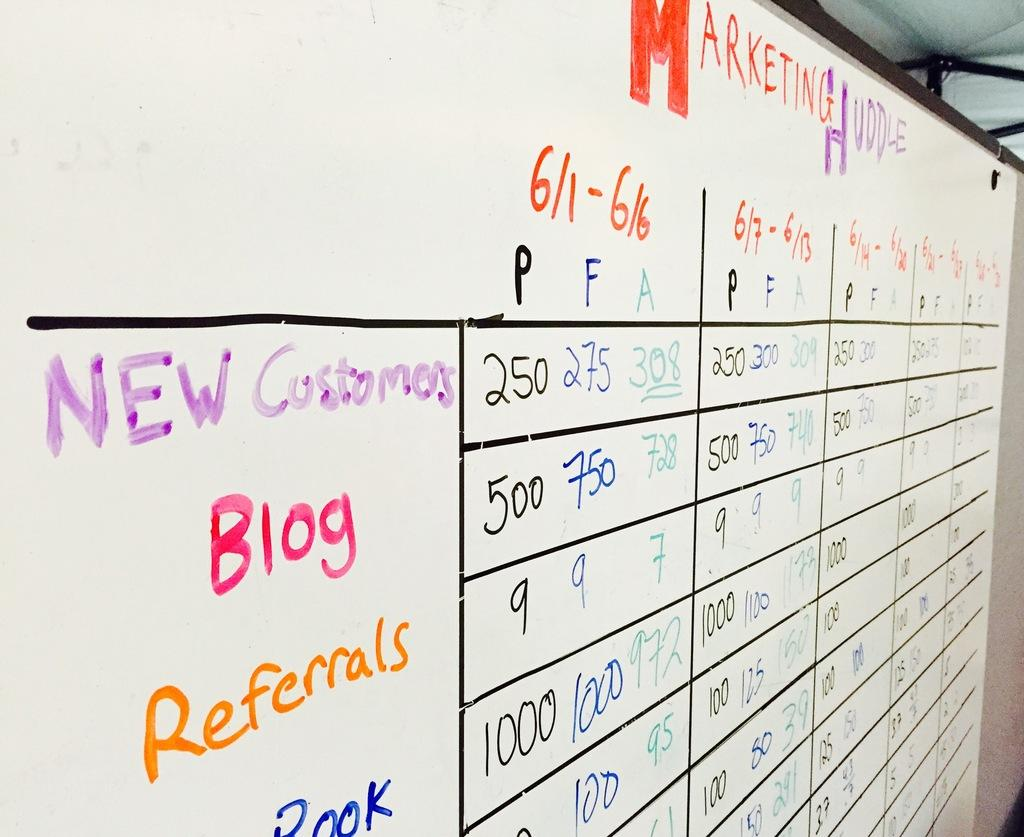What is the main object in the image? There is a whiteboard in the image. What is on the whiteboard? There is writing on the whiteboard. Are there any other objects visible in the image? Yes, there are small black poles in the top right corner of the image. What type of underwear is hanging on the whiteboard in the image? There is no underwear present in the image; it only features a whiteboard with writing and small black poles in the top right corner. 